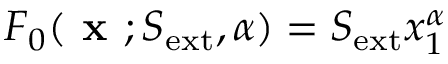Convert formula to latex. <formula><loc_0><loc_0><loc_500><loc_500>F _ { 0 } ( x ; S _ { e x t } , \alpha ) = S _ { e x t } x _ { 1 } ^ { \alpha }</formula> 